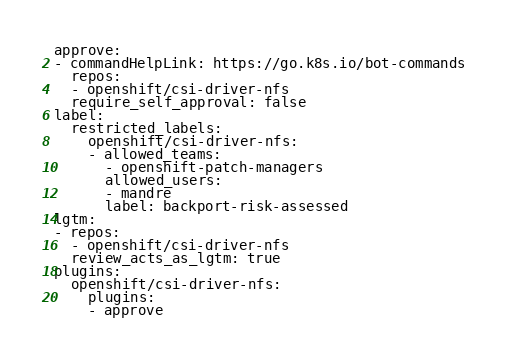<code> <loc_0><loc_0><loc_500><loc_500><_YAML_>approve:
- commandHelpLink: https://go.k8s.io/bot-commands
  repos:
  - openshift/csi-driver-nfs
  require_self_approval: false
label:
  restricted_labels:
    openshift/csi-driver-nfs:
    - allowed_teams:
      - openshift-patch-managers
      allowed_users:
      - mandre
      label: backport-risk-assessed
lgtm:
- repos:
  - openshift/csi-driver-nfs
  review_acts_as_lgtm: true
plugins:
  openshift/csi-driver-nfs:
    plugins:
    - approve
</code> 